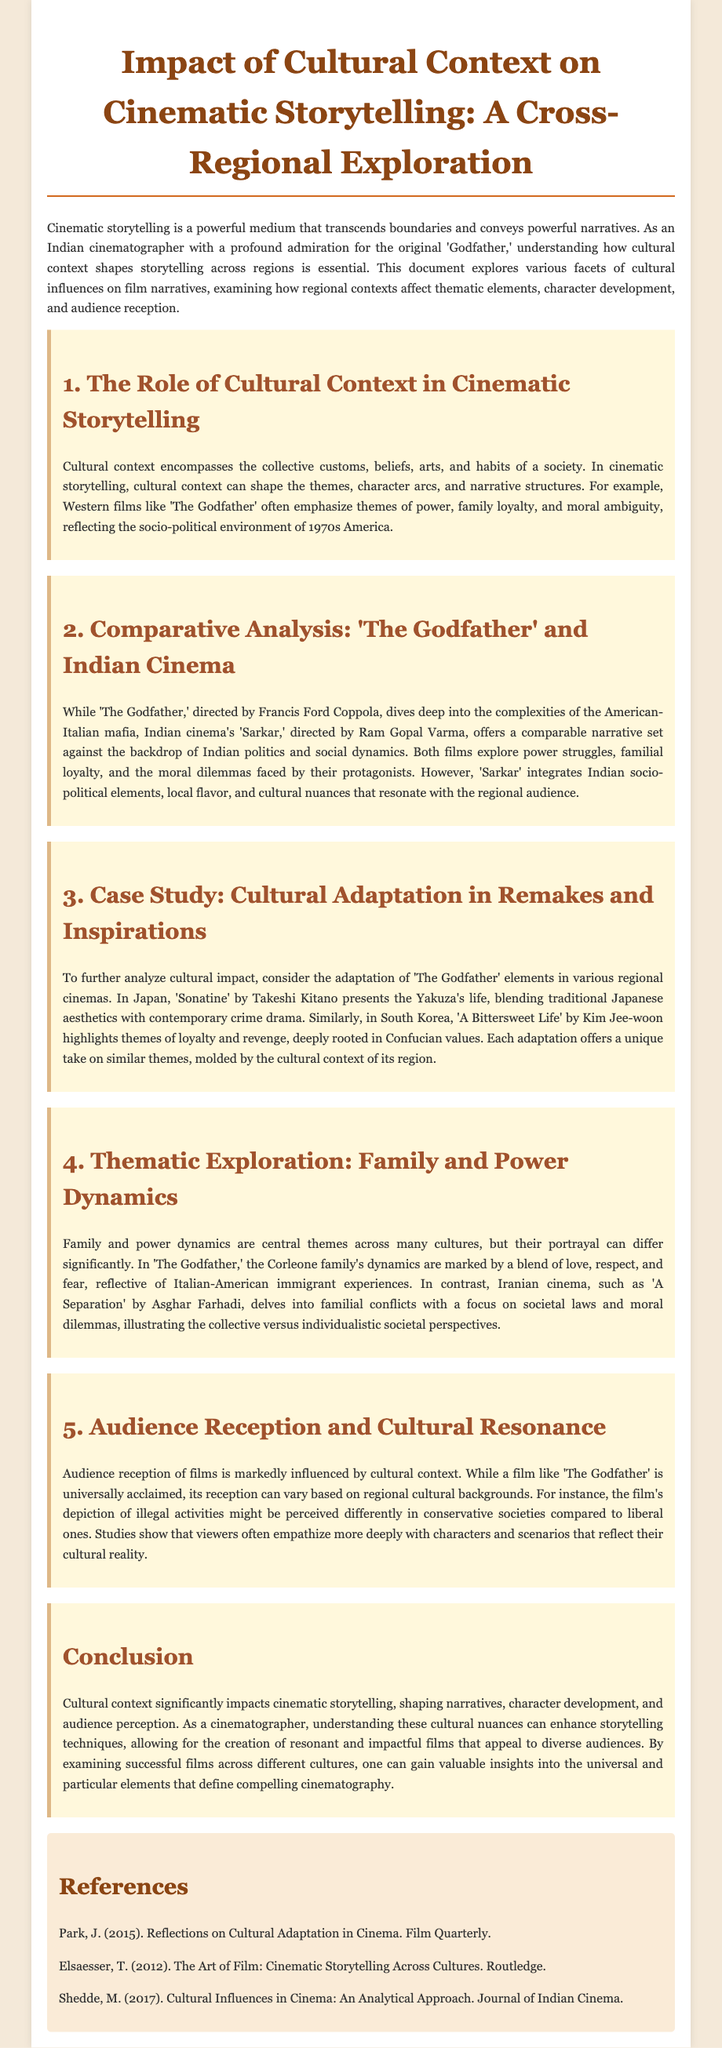What is the title of the document? The title is mentioned at the top of the document, indicating its focus on cultural context in cinematic storytelling.
Answer: Impact of Cultural Context on Cinematic Storytelling: A Cross-Regional Exploration Who directed 'The Godfather'? The document specifies that 'The Godfather' was directed by Francis Ford Coppola.
Answer: Francis Ford Coppola In which year was 'The Godfather' released? The release period mentioned in the document refers to the socio-political environment of 1970s America.
Answer: 1970s What is the name of the Indian film compared to 'The Godfather'? The document explicitly compares 'The Godfather' with an Indian film, called 'Sarkar'.
Answer: Sarkar Which cinema explores familial conflicts related to societal laws? The document specifies an Iranian cinema film that examines these themes.
Answer: A Separation What influences audience reception of films? The document states that audience reception is markedly influenced by cultural context.
Answer: Cultural context What themes are explored in both 'The Godfather' and 'Sarkar'? The document points out that both films explore similar themes, which can be directly cited.
Answer: Power struggles, familial loyalty, moral dilemmas Which cinematic technique is emphasized for creating impactful films? The document highlights the significance of understanding cultural nuances in filmmaking.
Answer: Cultural nuances 